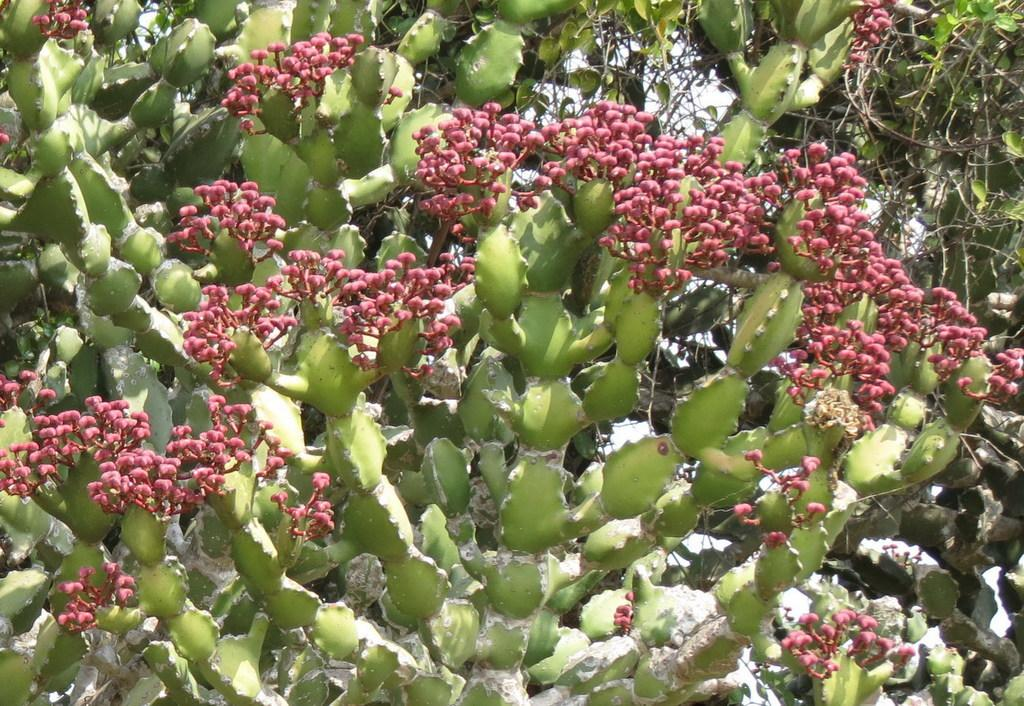What type of plants can be seen in the image? There are plants with flowers in the image. Can you describe the plants in the background of the image? There are plants in the background of the image, but their specific type is not mentioned. What can be seen in the sky in the background of the image? The sky is visible in the background of the image. What type of sail can be seen on the plants in the image? There is no sail present on the plants in the image; they are simply plants with flowers. 